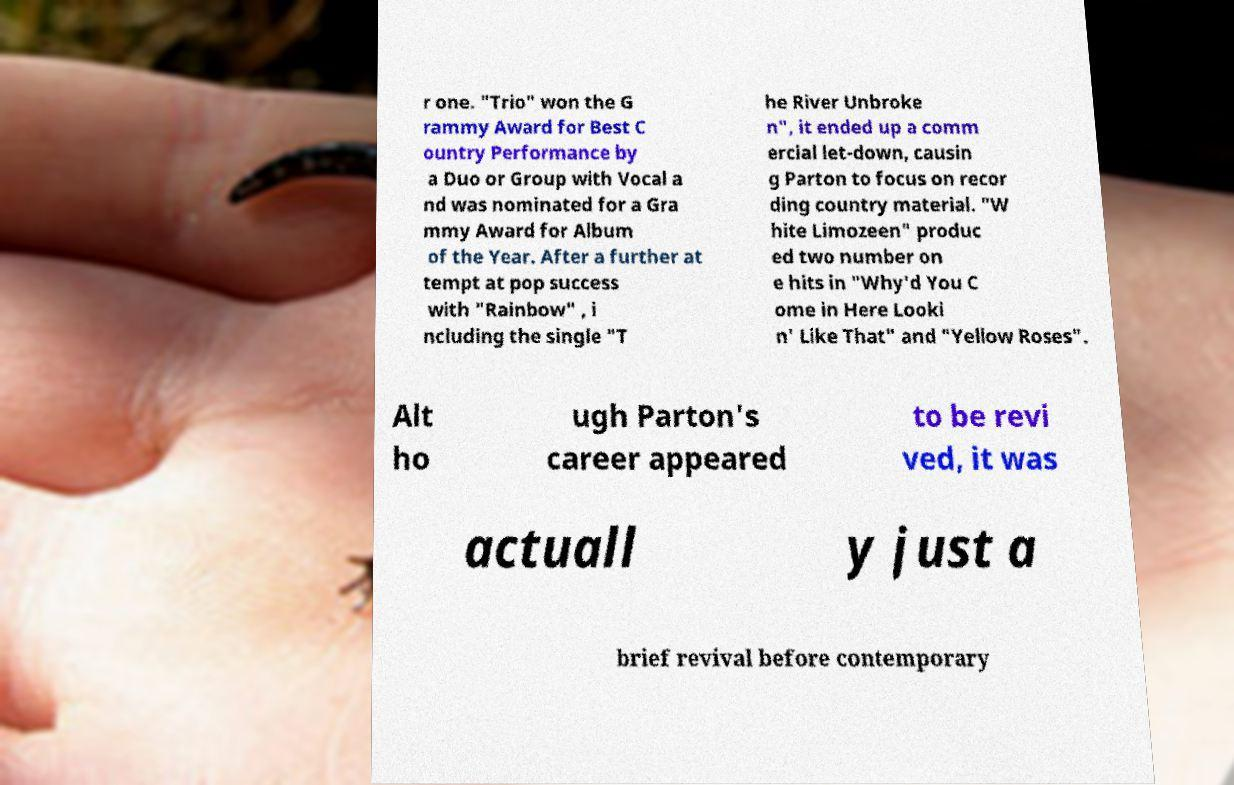What messages or text are displayed in this image? I need them in a readable, typed format. r one. "Trio" won the G rammy Award for Best C ountry Performance by a Duo or Group with Vocal a nd was nominated for a Gra mmy Award for Album of the Year. After a further at tempt at pop success with "Rainbow" , i ncluding the single "T he River Unbroke n", it ended up a comm ercial let-down, causin g Parton to focus on recor ding country material. "W hite Limozeen" produc ed two number on e hits in "Why'd You C ome in Here Looki n' Like That" and "Yellow Roses". Alt ho ugh Parton's career appeared to be revi ved, it was actuall y just a brief revival before contemporary 